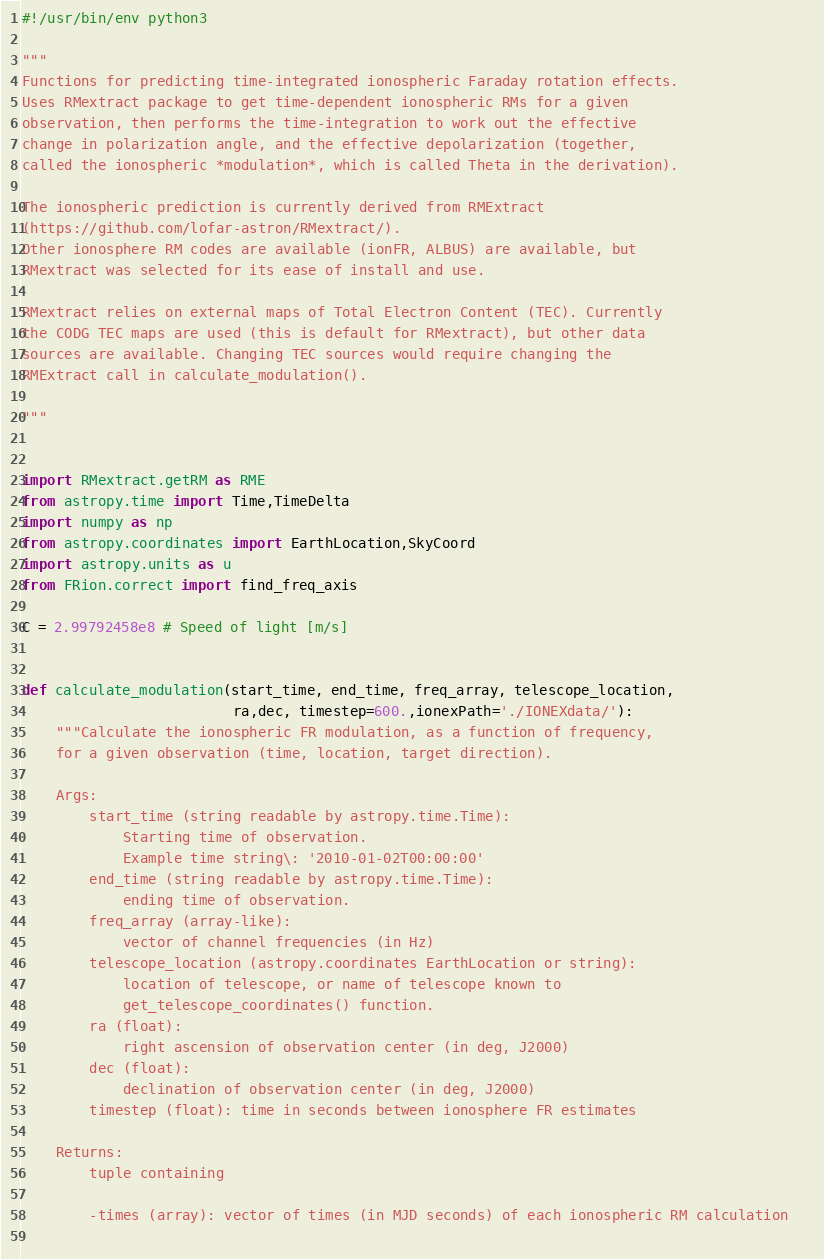Convert code to text. <code><loc_0><loc_0><loc_500><loc_500><_Python_>#!/usr/bin/env python3

"""
Functions for predicting time-integrated ionospheric Faraday rotation effects.
Uses RMextract package to get time-dependent ionospheric RMs for a given 
observation, then performs the time-integration to work out the effective
change in polarization angle, and the effective depolarization (together, 
called the ionospheric *modulation*, which is called Theta in the derivation).

The ionospheric prediction is currently derived from RMExtract
(https://github.com/lofar-astron/RMextract/). 
Other ionosphere RM codes are available (ionFR, ALBUS) are available, but 
RMextract was selected for its ease of install and use.

RMextract relies on external maps of Total Electron Content (TEC). Currently
the CODG TEC maps are used (this is default for RMextract), but other data
sources are available. Changing TEC sources would require changing the 
RMExtract call in calculate_modulation().

"""


import RMextract.getRM as RME
from astropy.time import Time,TimeDelta
import numpy as np
from astropy.coordinates import EarthLocation,SkyCoord
import astropy.units as u
from FRion.correct import find_freq_axis

C = 2.99792458e8 # Speed of light [m/s]


def calculate_modulation(start_time, end_time, freq_array, telescope_location,
                         ra,dec, timestep=600.,ionexPath='./IONEXdata/'):
    """Calculate the ionospheric FR modulation, as a function of frequency,
    for a given observation (time, location, target direction).
    
    Args:
        start_time (string readable by astropy.time.Time): 
            Starting time of observation.
            Example time string\: '2010-01-02T00:00:00'
        end_time (string readable by astropy.time.Time): 
            ending time of observation.
        freq_array (array-like): 
            vector of channel frequencies (in Hz)
        telescope_location (astropy.coordinates EarthLocation or string):
            location of telescope, or name of telescope known to 
            get_telescope_coordinates() function.
        ra (float): 
            right ascension of observation center (in deg, J2000)
        dec (float): 
            declination of observation center (in deg, J2000)
        timestep (float): time in seconds between ionosphere FR estimates
        
    Returns:
        tuple containing
        
        -times (array): vector of times (in MJD seconds) of each ionospheric RM calculation   
        </code> 